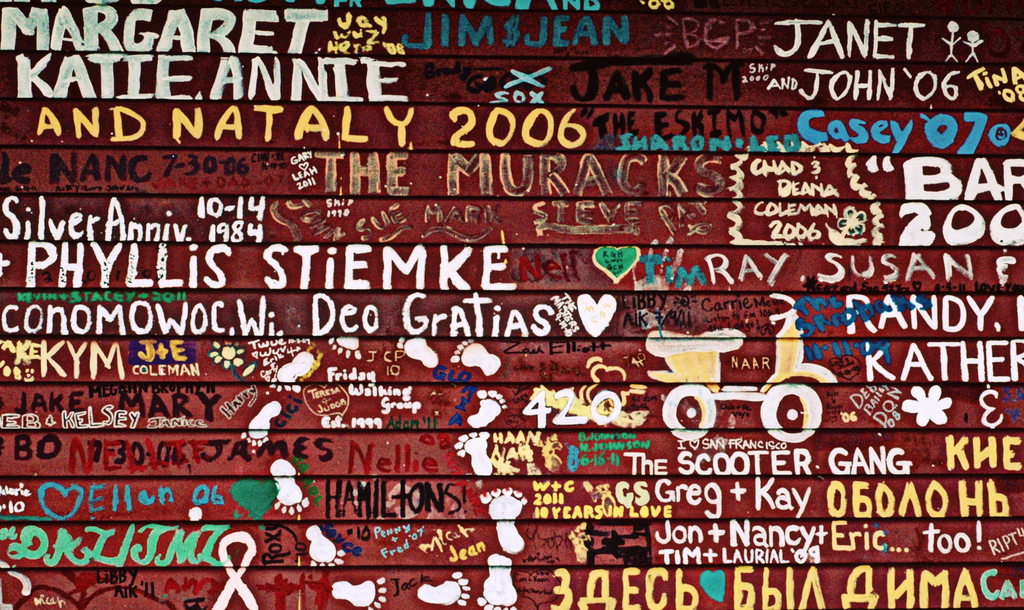What do you think 'The Scooter Gang' and '420oo' written on the wall represent? 'The Scooter Gang' likely represents a group of friends or a community bound by their enthusiasm for scooters, highlighting a shared hobby or interest. '420oo' might be an inside joke or code between friends, or simply playful graffiti, adding a layer of mystique and humor to the wall. 